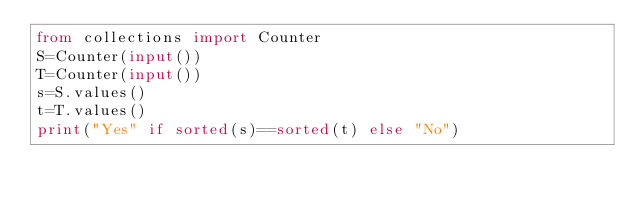<code> <loc_0><loc_0><loc_500><loc_500><_Python_>from collections import Counter
S=Counter(input())
T=Counter(input())
s=S.values()
t=T.values()
print("Yes" if sorted(s)==sorted(t) else "No")</code> 